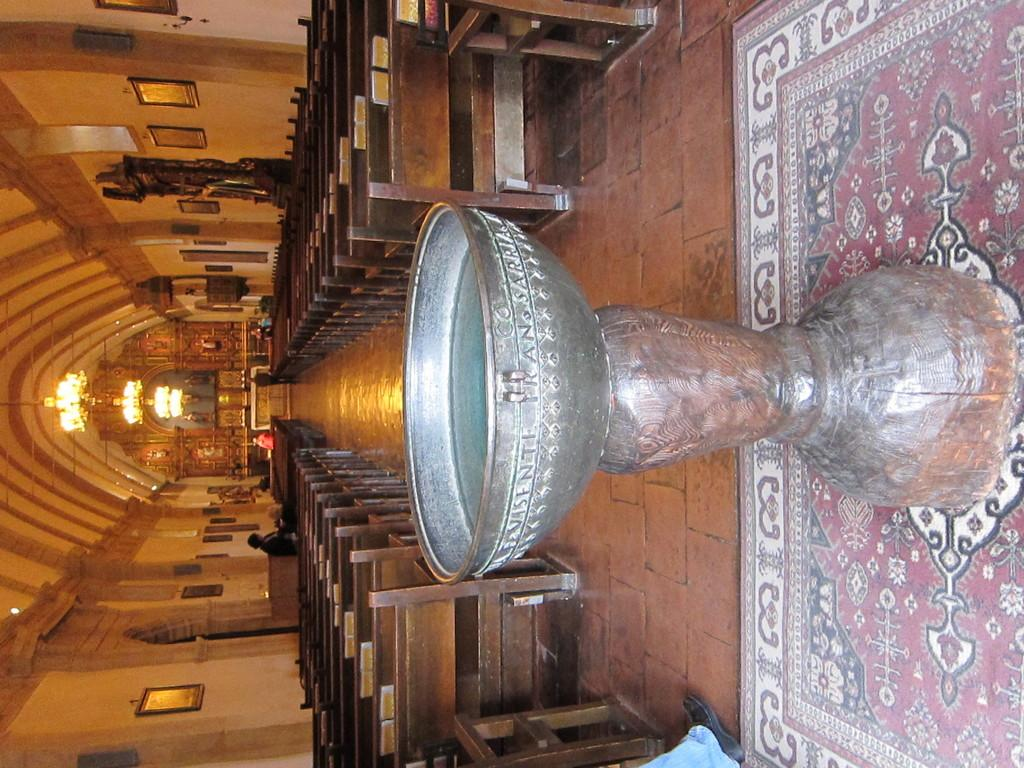What is the color of the object in the image? The object in the image is silver. What type of furniture can be seen in the image? There are benches in the image. What type of decorative items are present in the image? There are photo frames and chandeliers in the image. What architectural feature is visible in the image? There are arches in the image. Can you describe any other objects in the image? There are some other unspecified objects in the image. How many sisters are depicted in the image? There are no sisters depicted in the image. What type of wound can be seen on the chandelier in the image? There are no wounds present in the image, and the chandelier is not depicted as having any damage. 